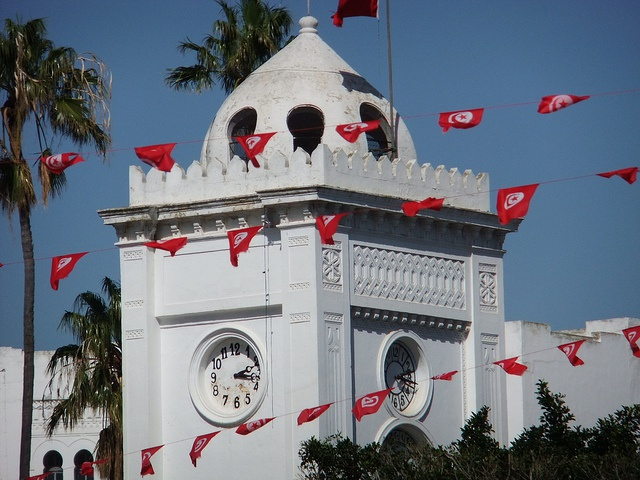Describe the objects in this image and their specific colors. I can see clock in darkblue, lightgray, darkgray, gray, and black tones and clock in darkblue, black, darkgray, and gray tones in this image. 